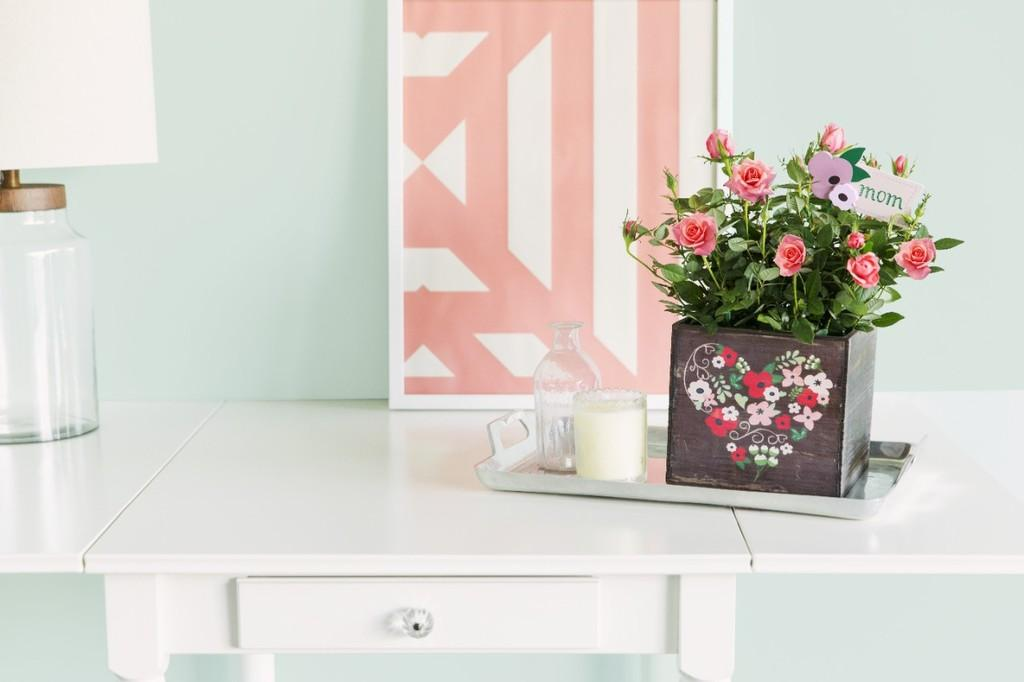What is on the table in the image? There is a picture, a tray, a bottle, a candle, a plant, and a lantern lamp on the table. Can you describe the picture on the table? The facts provided do not give any details about the picture on the table. What is the purpose of the tray on the table? The purpose of the tray on the table is not specified in the facts provided. What type of bottle is on the table? The facts provided do not specify the type of bottle on the table. What kind of plant is on the table? The facts provided do not specify the type of plant on the table. What is the function of the lantern lamp on the table? The function of the lantern lamp on the table is not specified in the facts provided. What color is the wall behind the table in the image? There is no mention of a wall behind the table in the image, so we cannot determine its color. 